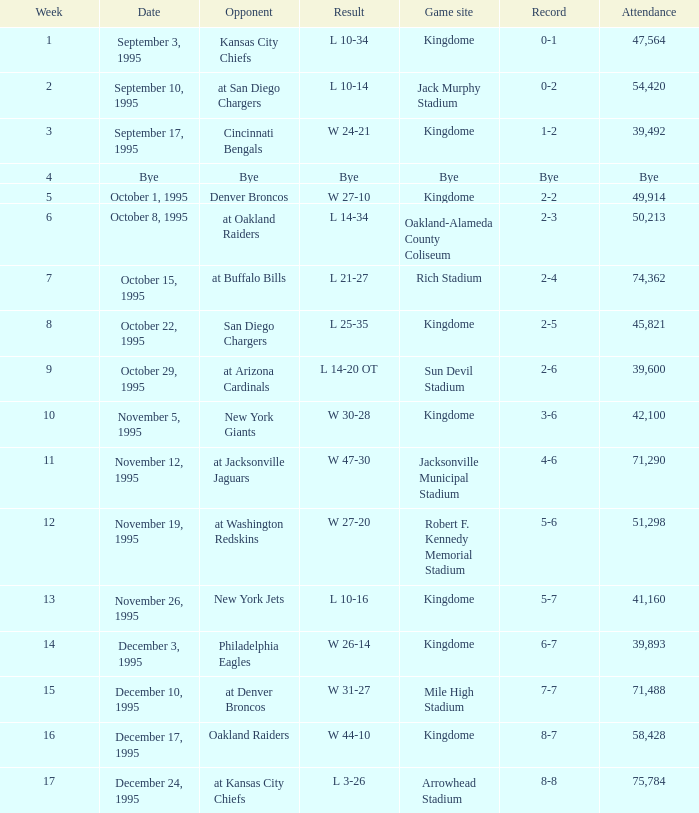Who was the adversary when the seattle seahawks had a 0-1 record? Kansas City Chiefs. 